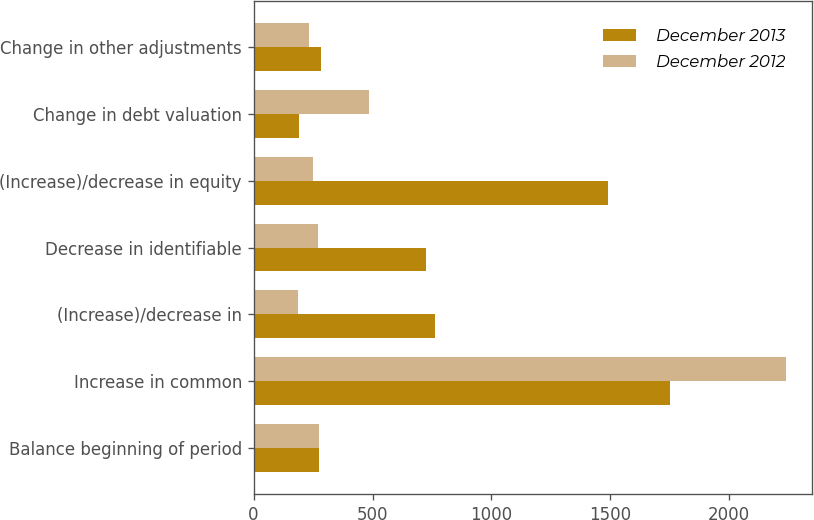Convert chart. <chart><loc_0><loc_0><loc_500><loc_500><stacked_bar_chart><ecel><fcel>Balance beginning of period<fcel>Increase in common<fcel>(Increase)/decrease in<fcel>Decrease in identifiable<fcel>(Increase)/decrease in equity<fcel>Change in debt valuation<fcel>Change in other adjustments<nl><fcel>December 2013<fcel>276<fcel>1751<fcel>763<fcel>726<fcel>1491<fcel>190<fcel>283<nl><fcel>December 2012<fcel>276<fcel>2237<fcel>188<fcel>269<fcel>249<fcel>484<fcel>232<nl></chart> 